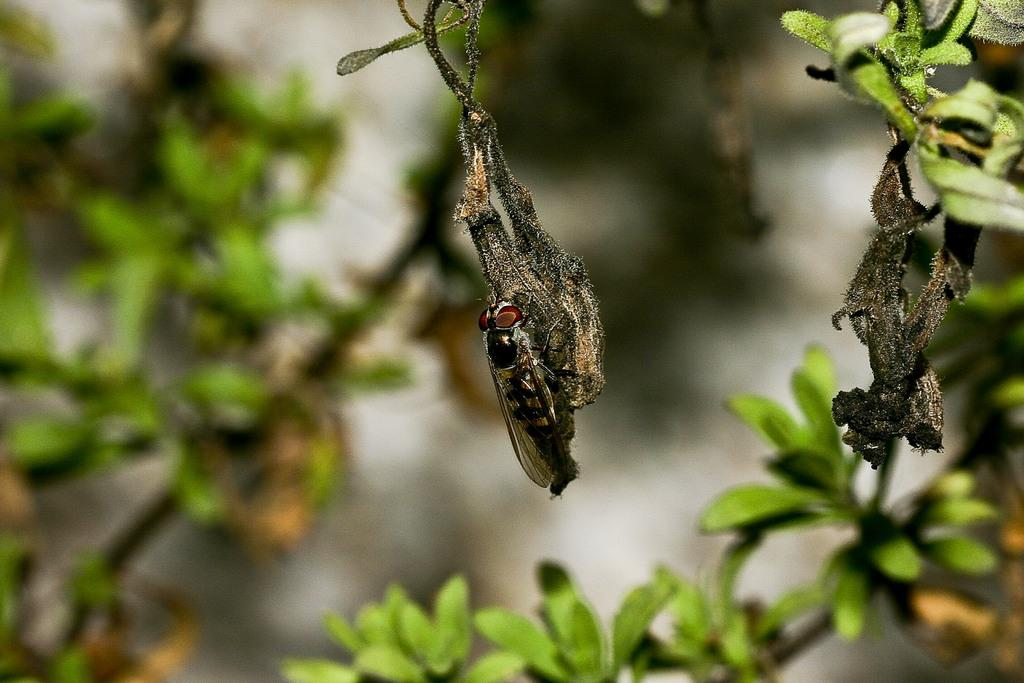Where was the picture taken? The picture was clicked outside. What can be seen in the center of the image? There is a fly on an object in the center of the image. What type of vegetation is visible in the image? There are green leaves visible in the image. How would you describe the background of the image? The background of the image is blurry. What industry is depicted in the image? There is no specific industry depicted in the image; it features a fly on an object with green leaves in the background. 